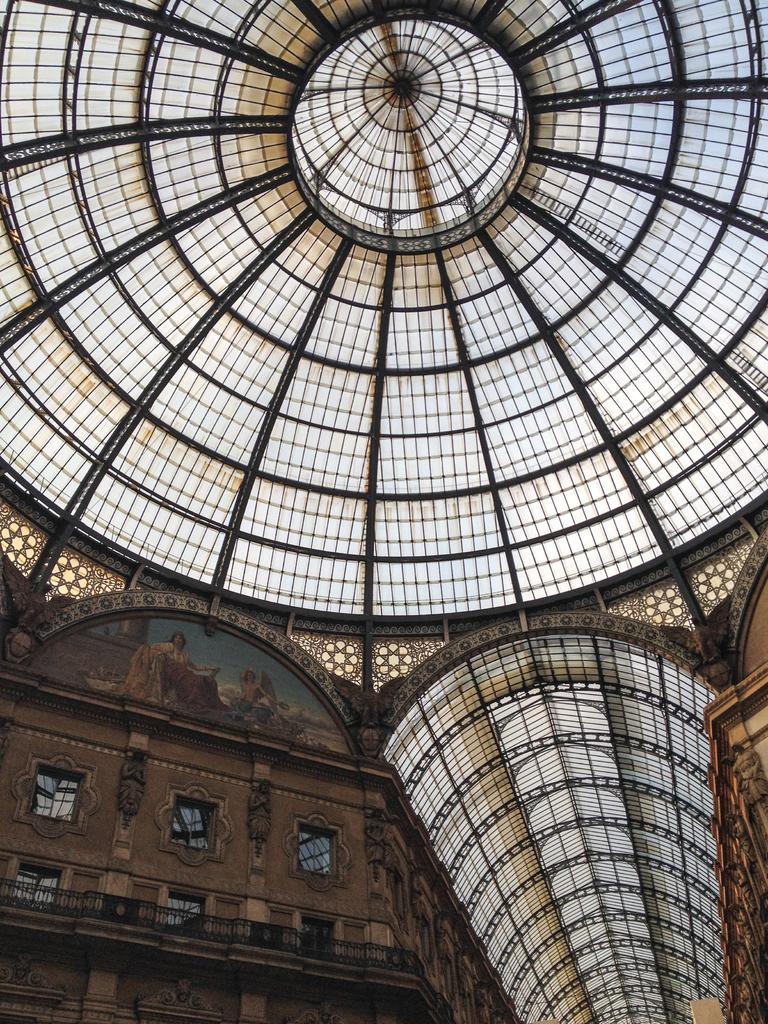How would you summarize this image in a sentence or two? In this image we can see the roof of a building. We can also see some windows, the railing and some pictures on a wall. 